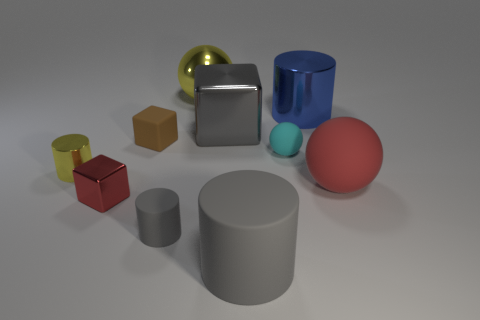There is a yellow ball; is its size the same as the yellow shiny object that is in front of the big blue object?
Give a very brief answer. No. What number of matte objects are tiny cyan spheres or green spheres?
Your answer should be very brief. 1. Do the big block and the metal cylinder right of the brown cube have the same color?
Give a very brief answer. No. What shape is the small cyan rubber thing?
Your answer should be compact. Sphere. There is a gray matte cylinder that is to the right of the metallic object that is behind the metallic cylinder right of the small cyan object; how big is it?
Ensure brevity in your answer.  Large. How many other objects are the same shape as the blue thing?
Your answer should be compact. 3. Is the shape of the large gray object that is behind the big red matte sphere the same as the tiny matte object behind the tiny cyan ball?
Provide a succinct answer. Yes. What number of cylinders are either red things or yellow metal things?
Your response must be concise. 1. What material is the red thing that is to the right of the yellow thing that is behind the yellow shiny object that is to the left of the yellow sphere?
Offer a terse response. Rubber. How many other things are there of the same size as the brown rubber thing?
Your answer should be very brief. 4. 